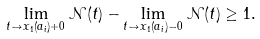<formula> <loc_0><loc_0><loc_500><loc_500>\lim _ { t \to x _ { 1 } ( a _ { i } ) + 0 } { \mathcal { N } } ( t ) - \lim _ { t \to x _ { 1 } ( a _ { i } ) - 0 } { \mathcal { N } } ( t ) \geq 1 .</formula> 